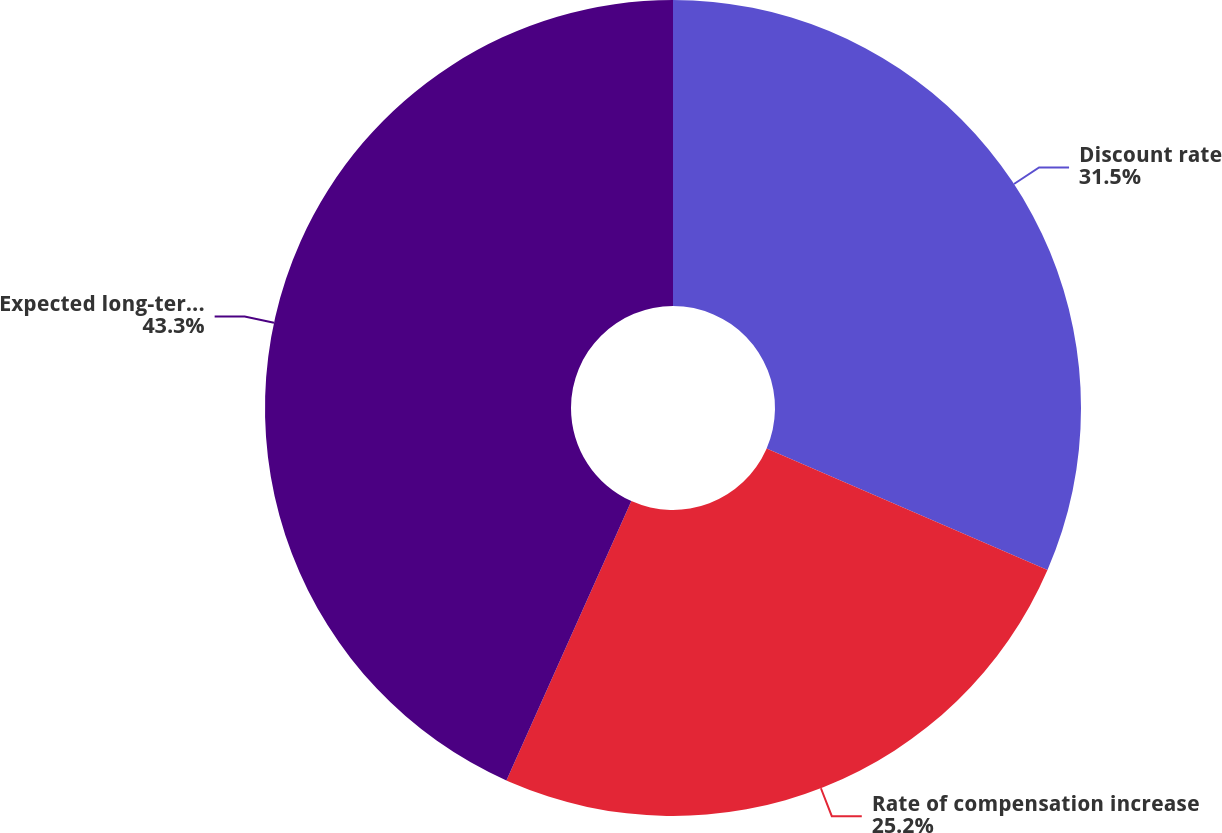Convert chart. <chart><loc_0><loc_0><loc_500><loc_500><pie_chart><fcel>Discount rate<fcel>Rate of compensation increase<fcel>Expected long-term rate of<nl><fcel>31.5%<fcel>25.2%<fcel>43.31%<nl></chart> 